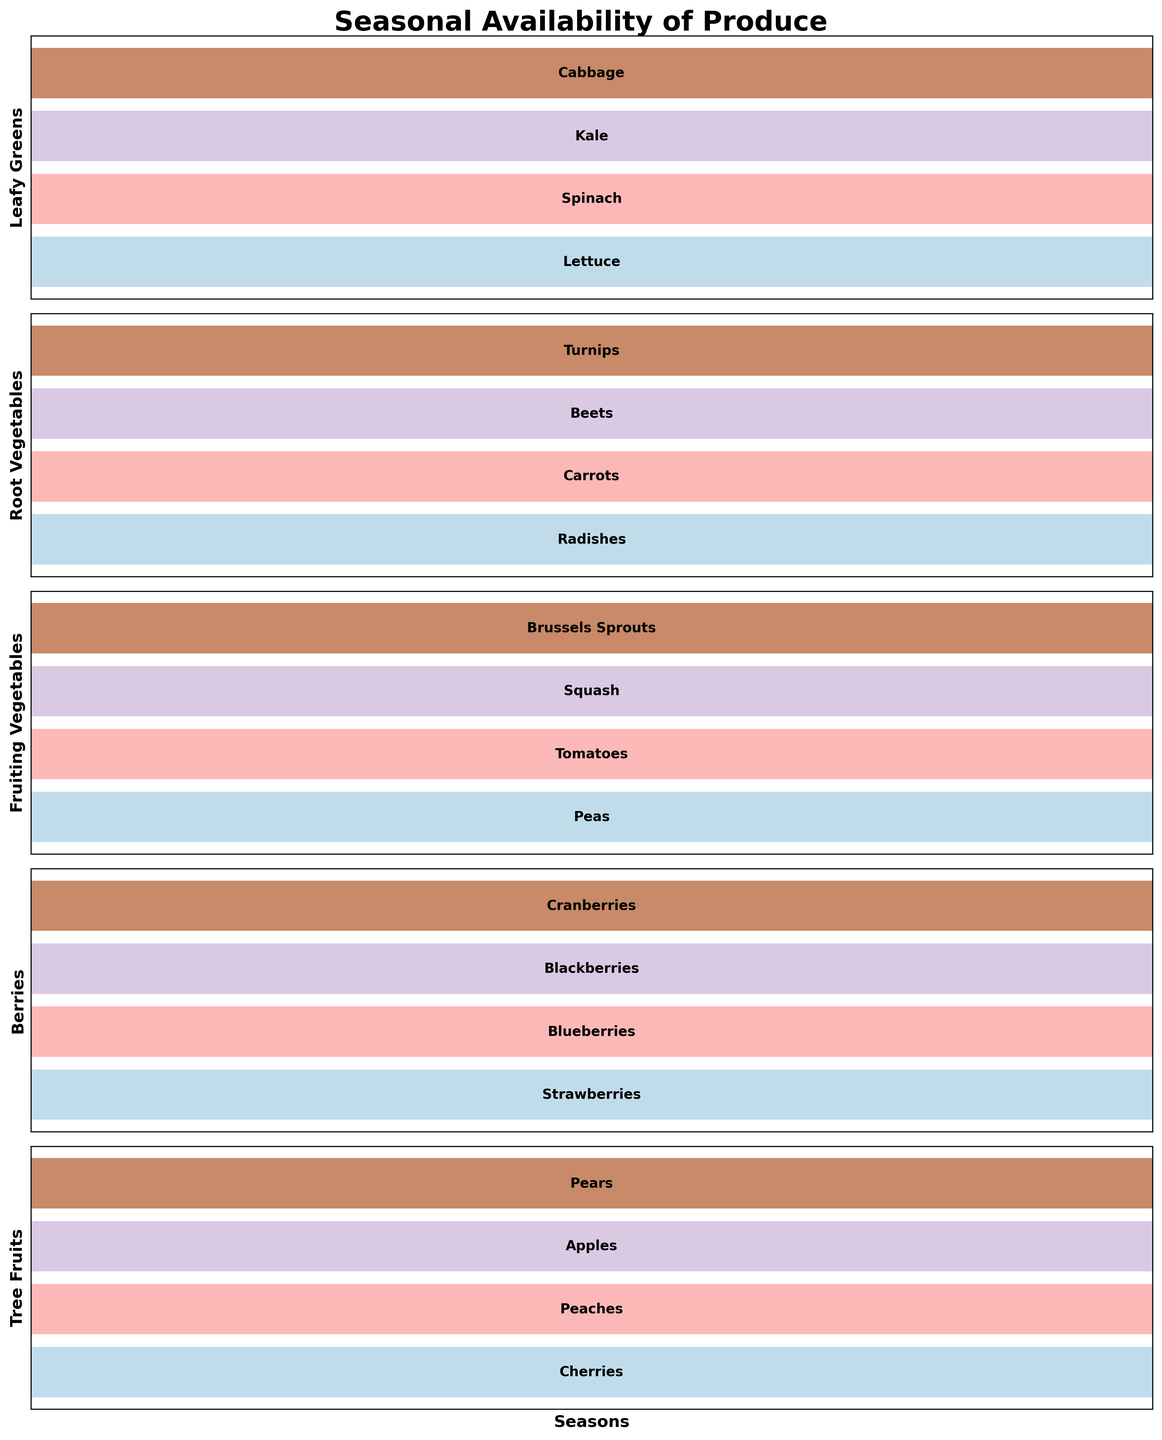Which season has the highest variety of leafy greens? Each subplot represents a type of produce. By checking the 'Leafy Greens' subplot, we see that each season has one type of leafy green listed. Thus, no season has more variety than another.
Answer: No season Which category of produce has kale listed, and in which season? To find kale, look at the 'Leafy Greens' subplot. The text next to the fall season shows kale.
Answer: Leafy Greens, Fall In which season are carrots available? By looking at the 'Root Vegetables' subplot, we see that carrots are listed next to the summer season.
Answer: Summer What are all the fruits available in winter? Examine the 'Berries' and 'Tree Fruits' subplots for winter. Winter entries for berries and tree fruits are cranberries and pears, respectively.
Answer: Cranberries, Pears Which season offers the highest variety of berries? Each subplot shows one entry per season; hence, no season has more variety in berries than another.
Answer: No season Compare the availability of root vegetables in spring and fall. How are they different? In the 'Root Vegetables' subplot, the spring season lists radishes, while fall lists beets. The difference is the type of root vegetable available.
Answer: Radishes in spring, Beets in fall How many different types of fruiting vegetables are available throughout the year? Check the 'Fruiting Vegetables' subplot. There is one type listed for each season: peas (spring), tomatoes (summer), squash (fall), and Brussels sprouts (winter), making a total of four.
Answer: Four Can we find any leafy green vegetable available in both winter and summer? The 'Leafy Greens' subplot shows cabbage in winter and spinach in summer. Since these are different, no leafy green is available in both seasons.
Answer: No Which season provides the maximum diversity in tree fruits? The 'Tree Fruits' subplot with a single type of fruit for each season means no season offers more diversity than another.
Answer: No season What is the commonality in fruit categories available in both spring and fall? In the 'Berries' and 'Tree Fruits' subplots, spring and fall have strawberries and blackberries for berries, cherries, and apples for tree fruits, showing no commonality.
Answer: None 